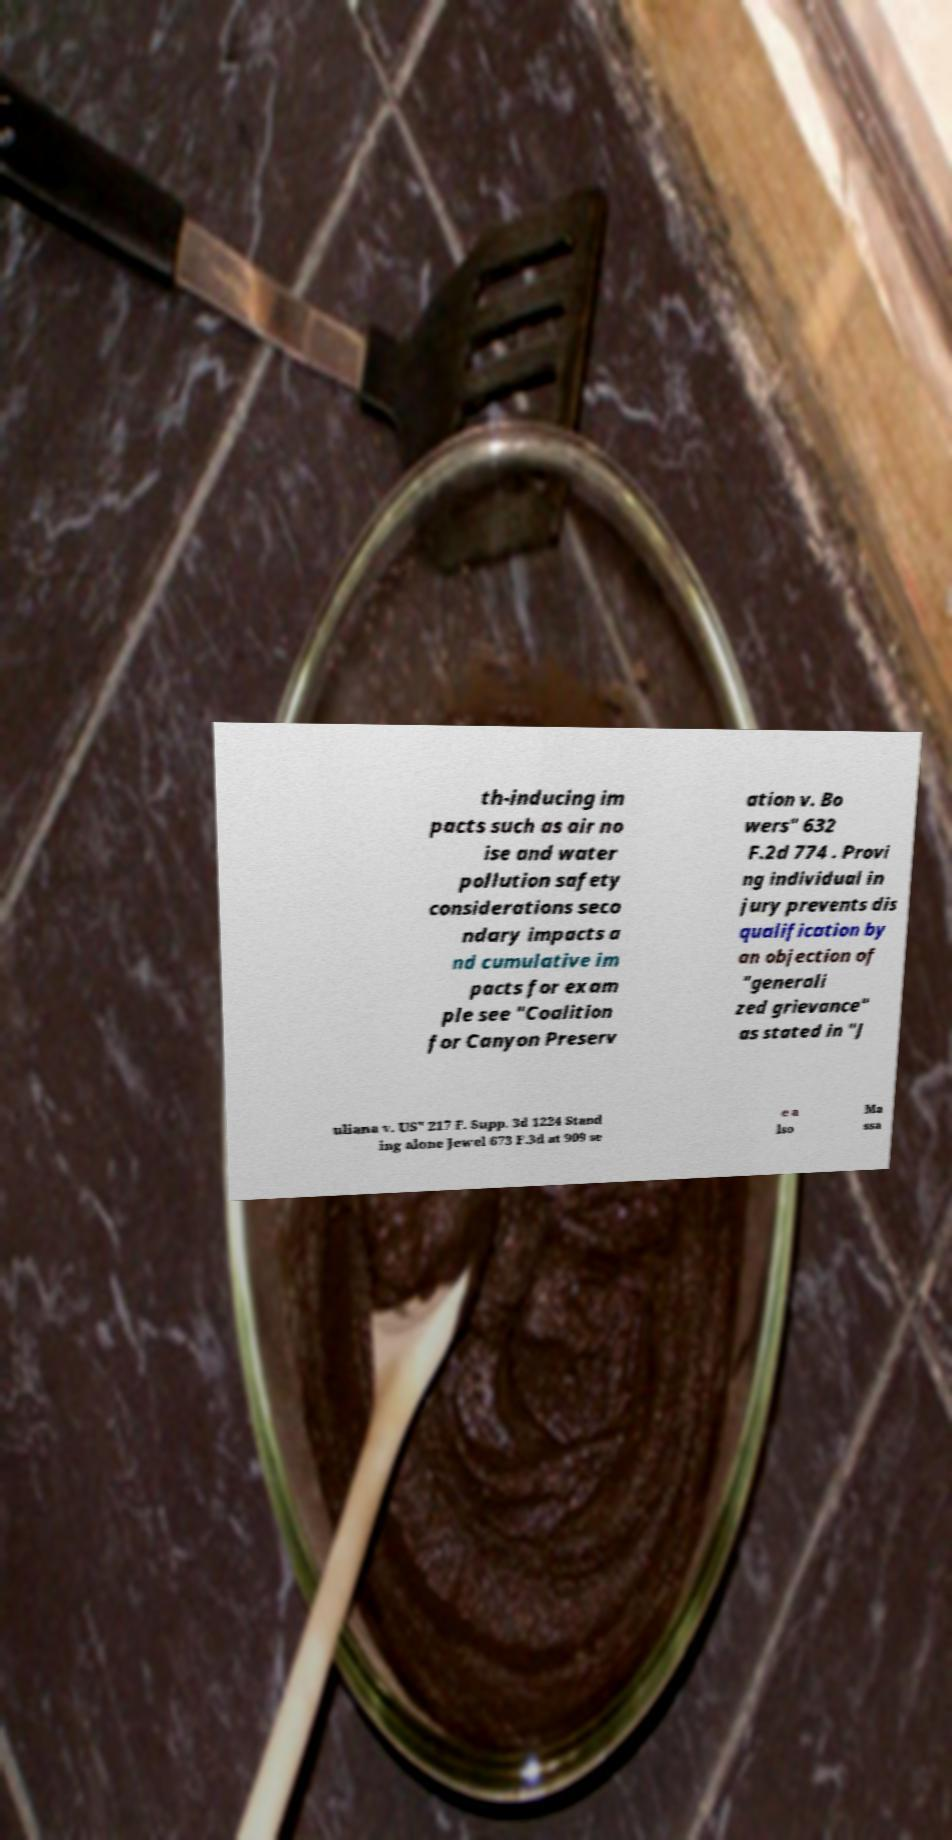Please identify and transcribe the text found in this image. th-inducing im pacts such as air no ise and water pollution safety considerations seco ndary impacts a nd cumulative im pacts for exam ple see "Coalition for Canyon Preserv ation v. Bo wers" 632 F.2d 774 . Provi ng individual in jury prevents dis qualification by an objection of "generali zed grievance" as stated in "J uliana v. US" 217 F. Supp. 3d 1224 Stand ing alone Jewel 673 F.3d at 909 se e a lso Ma ssa 